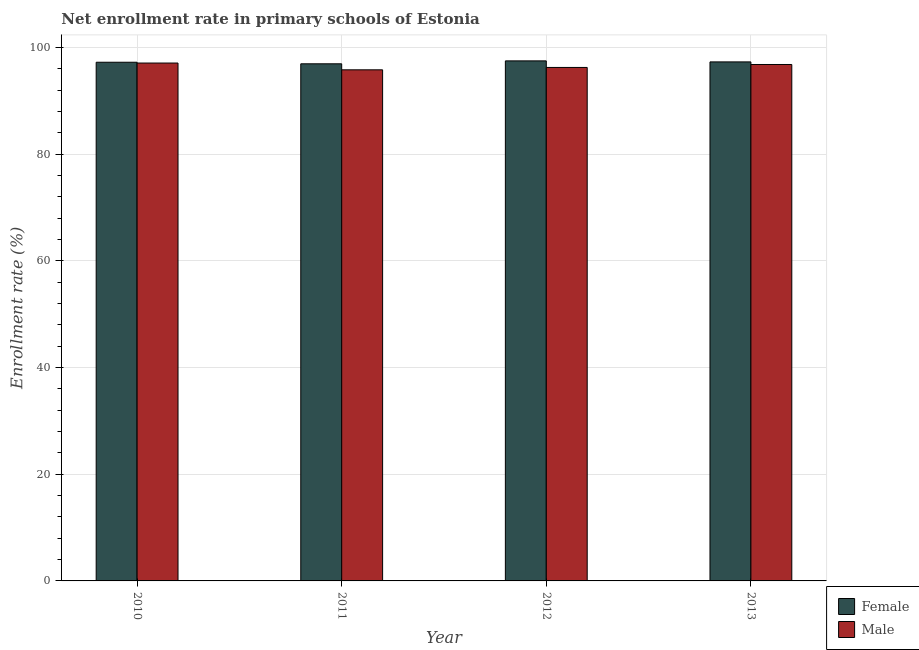How many different coloured bars are there?
Provide a short and direct response. 2. How many groups of bars are there?
Offer a very short reply. 4. How many bars are there on the 4th tick from the left?
Offer a terse response. 2. How many bars are there on the 4th tick from the right?
Your answer should be compact. 2. What is the enrollment rate of male students in 2010?
Give a very brief answer. 97.08. Across all years, what is the maximum enrollment rate of male students?
Keep it short and to the point. 97.08. Across all years, what is the minimum enrollment rate of male students?
Make the answer very short. 95.81. In which year was the enrollment rate of male students maximum?
Make the answer very short. 2010. What is the total enrollment rate of female students in the graph?
Provide a short and direct response. 388.94. What is the difference between the enrollment rate of female students in 2010 and that in 2011?
Your answer should be very brief. 0.29. What is the difference between the enrollment rate of female students in 2011 and the enrollment rate of male students in 2012?
Your answer should be compact. -0.55. What is the average enrollment rate of male students per year?
Your response must be concise. 96.49. What is the ratio of the enrollment rate of female students in 2010 to that in 2012?
Your response must be concise. 1. Is the enrollment rate of female students in 2012 less than that in 2013?
Provide a short and direct response. No. Is the difference between the enrollment rate of female students in 2010 and 2013 greater than the difference between the enrollment rate of male students in 2010 and 2013?
Your answer should be compact. No. What is the difference between the highest and the second highest enrollment rate of male students?
Your answer should be very brief. 0.27. What is the difference between the highest and the lowest enrollment rate of female students?
Give a very brief answer. 0.55. Is the sum of the enrollment rate of male students in 2010 and 2013 greater than the maximum enrollment rate of female students across all years?
Your response must be concise. Yes. What does the 1st bar from the left in 2012 represents?
Offer a terse response. Female. What does the 1st bar from the right in 2011 represents?
Ensure brevity in your answer.  Male. How many bars are there?
Provide a short and direct response. 8. Are the values on the major ticks of Y-axis written in scientific E-notation?
Keep it short and to the point. No. Does the graph contain any zero values?
Keep it short and to the point. No. Where does the legend appear in the graph?
Offer a terse response. Bottom right. What is the title of the graph?
Offer a very short reply. Net enrollment rate in primary schools of Estonia. Does "Banks" appear as one of the legend labels in the graph?
Provide a short and direct response. No. What is the label or title of the X-axis?
Offer a very short reply. Year. What is the label or title of the Y-axis?
Offer a very short reply. Enrollment rate (%). What is the Enrollment rate (%) in Female in 2010?
Ensure brevity in your answer.  97.23. What is the Enrollment rate (%) in Male in 2010?
Keep it short and to the point. 97.08. What is the Enrollment rate (%) of Female in 2011?
Offer a very short reply. 96.93. What is the Enrollment rate (%) of Male in 2011?
Offer a very short reply. 95.81. What is the Enrollment rate (%) of Female in 2012?
Offer a very short reply. 97.48. What is the Enrollment rate (%) of Male in 2012?
Ensure brevity in your answer.  96.25. What is the Enrollment rate (%) in Female in 2013?
Your answer should be very brief. 97.29. What is the Enrollment rate (%) of Male in 2013?
Your answer should be very brief. 96.81. Across all years, what is the maximum Enrollment rate (%) in Female?
Offer a very short reply. 97.48. Across all years, what is the maximum Enrollment rate (%) of Male?
Keep it short and to the point. 97.08. Across all years, what is the minimum Enrollment rate (%) in Female?
Offer a terse response. 96.93. Across all years, what is the minimum Enrollment rate (%) in Male?
Your answer should be very brief. 95.81. What is the total Enrollment rate (%) in Female in the graph?
Keep it short and to the point. 388.94. What is the total Enrollment rate (%) of Male in the graph?
Make the answer very short. 385.94. What is the difference between the Enrollment rate (%) of Female in 2010 and that in 2011?
Offer a very short reply. 0.29. What is the difference between the Enrollment rate (%) of Male in 2010 and that in 2011?
Give a very brief answer. 1.27. What is the difference between the Enrollment rate (%) in Female in 2010 and that in 2012?
Provide a succinct answer. -0.26. What is the difference between the Enrollment rate (%) of Male in 2010 and that in 2012?
Make the answer very short. 0.83. What is the difference between the Enrollment rate (%) of Female in 2010 and that in 2013?
Offer a very short reply. -0.06. What is the difference between the Enrollment rate (%) of Male in 2010 and that in 2013?
Ensure brevity in your answer.  0.27. What is the difference between the Enrollment rate (%) of Female in 2011 and that in 2012?
Your response must be concise. -0.55. What is the difference between the Enrollment rate (%) in Male in 2011 and that in 2012?
Your answer should be compact. -0.44. What is the difference between the Enrollment rate (%) in Female in 2011 and that in 2013?
Your answer should be compact. -0.36. What is the difference between the Enrollment rate (%) in Male in 2011 and that in 2013?
Provide a succinct answer. -1. What is the difference between the Enrollment rate (%) in Female in 2012 and that in 2013?
Give a very brief answer. 0.19. What is the difference between the Enrollment rate (%) in Male in 2012 and that in 2013?
Ensure brevity in your answer.  -0.55. What is the difference between the Enrollment rate (%) of Female in 2010 and the Enrollment rate (%) of Male in 2011?
Give a very brief answer. 1.42. What is the difference between the Enrollment rate (%) in Female in 2010 and the Enrollment rate (%) in Male in 2012?
Keep it short and to the point. 0.98. What is the difference between the Enrollment rate (%) in Female in 2010 and the Enrollment rate (%) in Male in 2013?
Your answer should be very brief. 0.42. What is the difference between the Enrollment rate (%) in Female in 2011 and the Enrollment rate (%) in Male in 2012?
Give a very brief answer. 0.68. What is the difference between the Enrollment rate (%) in Female in 2011 and the Enrollment rate (%) in Male in 2013?
Make the answer very short. 0.13. What is the difference between the Enrollment rate (%) of Female in 2012 and the Enrollment rate (%) of Male in 2013?
Provide a succinct answer. 0.68. What is the average Enrollment rate (%) in Female per year?
Give a very brief answer. 97.23. What is the average Enrollment rate (%) in Male per year?
Make the answer very short. 96.49. In the year 2010, what is the difference between the Enrollment rate (%) in Female and Enrollment rate (%) in Male?
Make the answer very short. 0.15. In the year 2011, what is the difference between the Enrollment rate (%) in Female and Enrollment rate (%) in Male?
Offer a terse response. 1.13. In the year 2012, what is the difference between the Enrollment rate (%) in Female and Enrollment rate (%) in Male?
Provide a succinct answer. 1.23. In the year 2013, what is the difference between the Enrollment rate (%) in Female and Enrollment rate (%) in Male?
Offer a very short reply. 0.48. What is the ratio of the Enrollment rate (%) in Female in 2010 to that in 2011?
Your response must be concise. 1. What is the ratio of the Enrollment rate (%) of Male in 2010 to that in 2011?
Give a very brief answer. 1.01. What is the ratio of the Enrollment rate (%) in Male in 2010 to that in 2012?
Make the answer very short. 1.01. What is the ratio of the Enrollment rate (%) in Female in 2011 to that in 2012?
Give a very brief answer. 0.99. What is the ratio of the Enrollment rate (%) in Female in 2012 to that in 2013?
Keep it short and to the point. 1. What is the ratio of the Enrollment rate (%) of Male in 2012 to that in 2013?
Offer a very short reply. 0.99. What is the difference between the highest and the second highest Enrollment rate (%) of Female?
Ensure brevity in your answer.  0.19. What is the difference between the highest and the second highest Enrollment rate (%) in Male?
Your answer should be very brief. 0.27. What is the difference between the highest and the lowest Enrollment rate (%) in Female?
Provide a succinct answer. 0.55. What is the difference between the highest and the lowest Enrollment rate (%) in Male?
Keep it short and to the point. 1.27. 